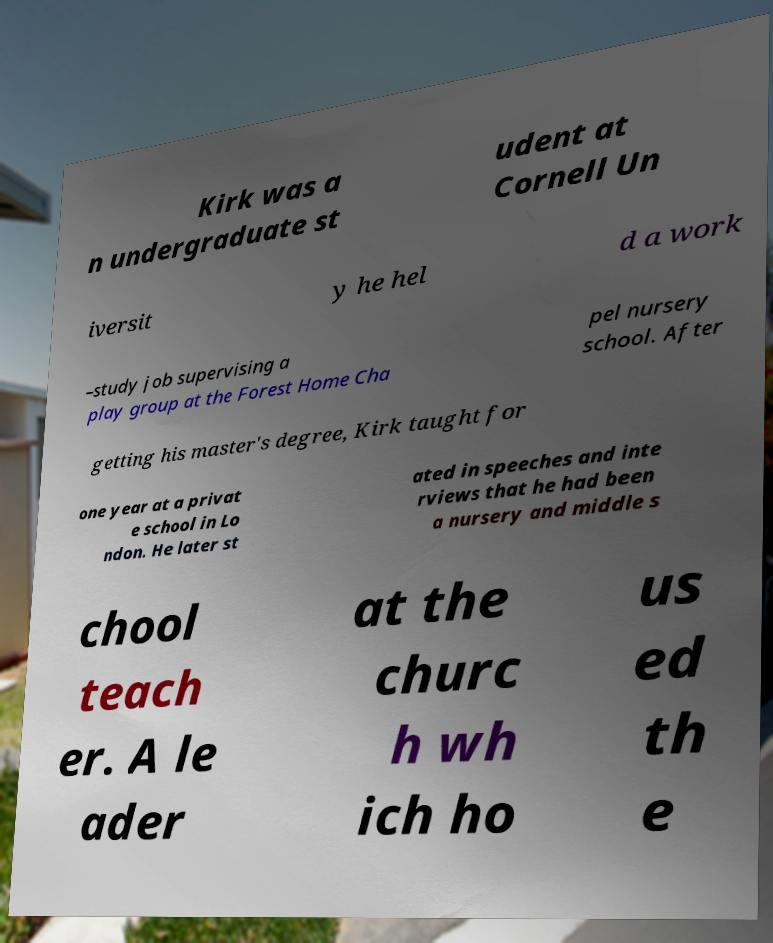Please identify and transcribe the text found in this image. Kirk was a n undergraduate st udent at Cornell Un iversit y he hel d a work –study job supervising a play group at the Forest Home Cha pel nursery school. After getting his master's degree, Kirk taught for one year at a privat e school in Lo ndon. He later st ated in speeches and inte rviews that he had been a nursery and middle s chool teach er. A le ader at the churc h wh ich ho us ed th e 